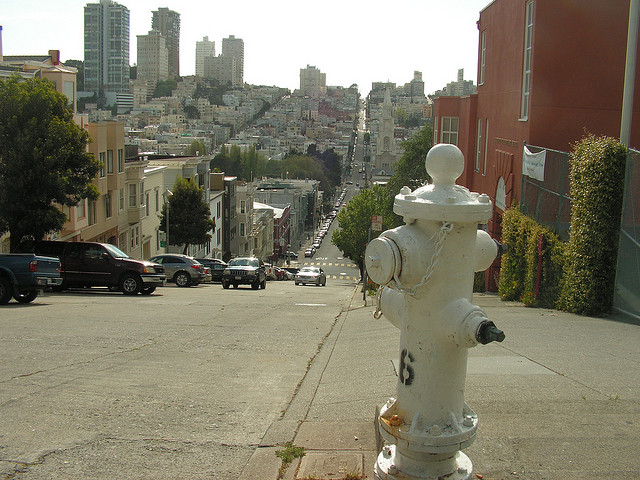Please identify all text content in this image. 6 